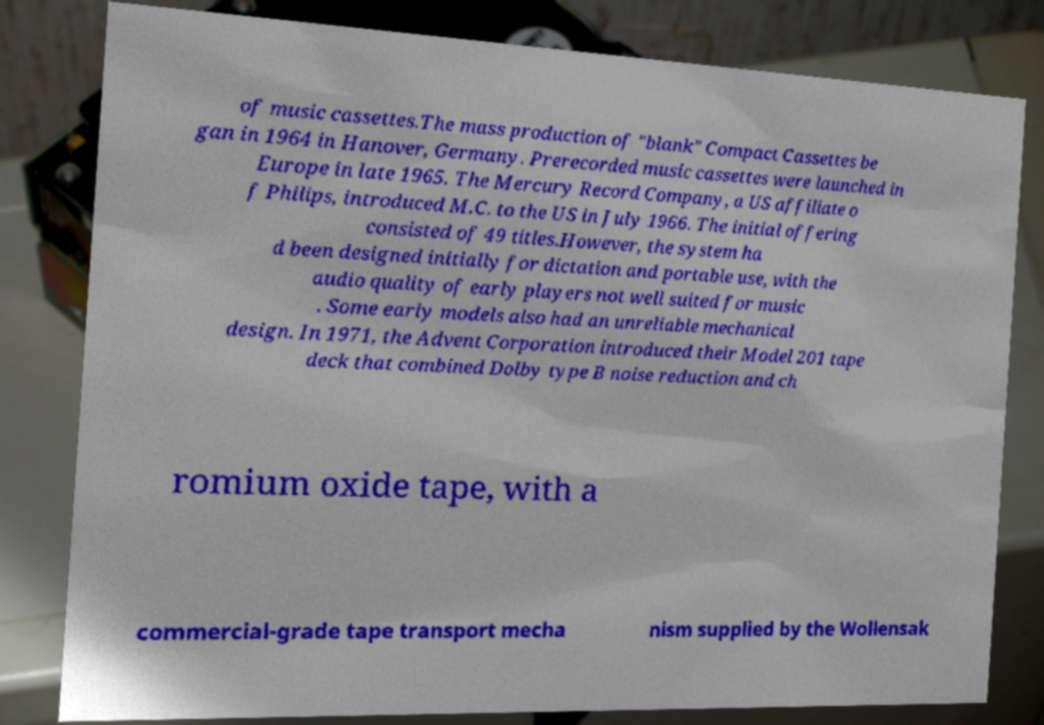I need the written content from this picture converted into text. Can you do that? of music cassettes.The mass production of "blank" Compact Cassettes be gan in 1964 in Hanover, Germany. Prerecorded music cassettes were launched in Europe in late 1965. The Mercury Record Company, a US affiliate o f Philips, introduced M.C. to the US in July 1966. The initial offering consisted of 49 titles.However, the system ha d been designed initially for dictation and portable use, with the audio quality of early players not well suited for music . Some early models also had an unreliable mechanical design. In 1971, the Advent Corporation introduced their Model 201 tape deck that combined Dolby type B noise reduction and ch romium oxide tape, with a commercial-grade tape transport mecha nism supplied by the Wollensak 